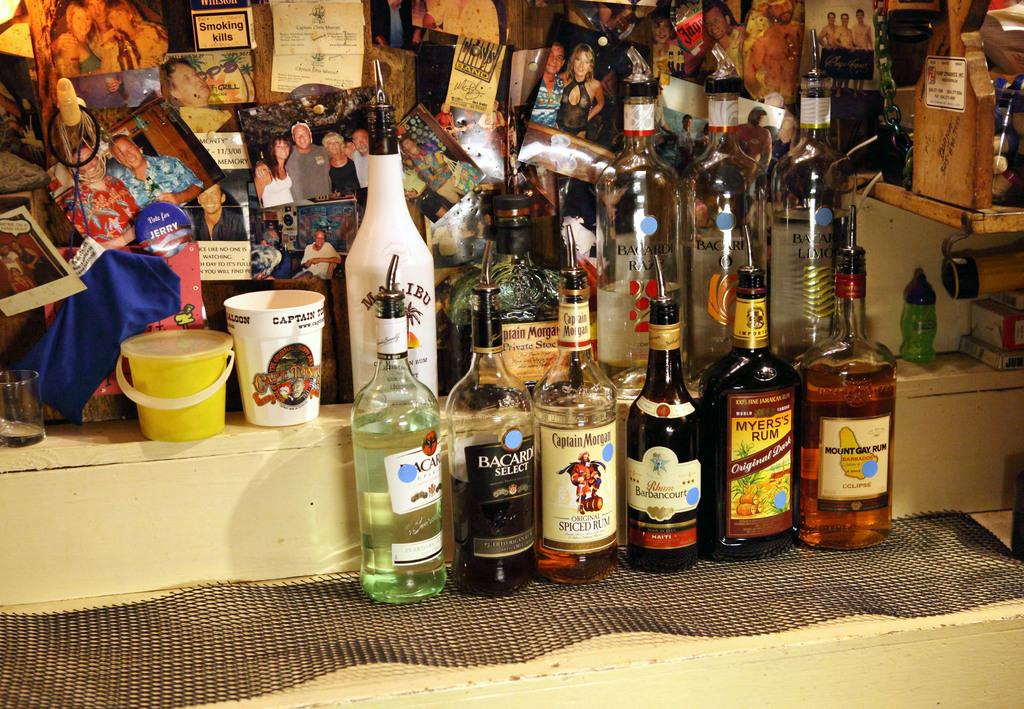Provide a one-sentence caption for the provided image. Bottle of Mount Gay Rum and A bottle of Bacardi Select. 